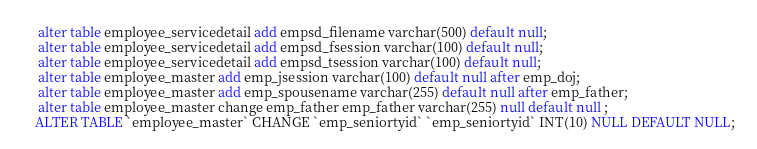<code> <loc_0><loc_0><loc_500><loc_500><_SQL_> alter table employee_servicedetail add empsd_filename varchar(500) default null;
 alter table employee_servicedetail add empsd_fsession varchar(100) default null;
 alter table employee_servicedetail add empsd_tsession varchar(100) default null;
 alter table employee_master add emp_jsession varchar(100) default null after emp_doj;
 alter table employee_master add emp_spousename varchar(255) default null after emp_father;
 alter table employee_master change emp_father emp_father varchar(255) null default null ;
ALTER TABLE `employee_master` CHANGE `emp_seniortyid` `emp_seniortyid` INT(10) NULL DEFAULT NULL;
</code> 